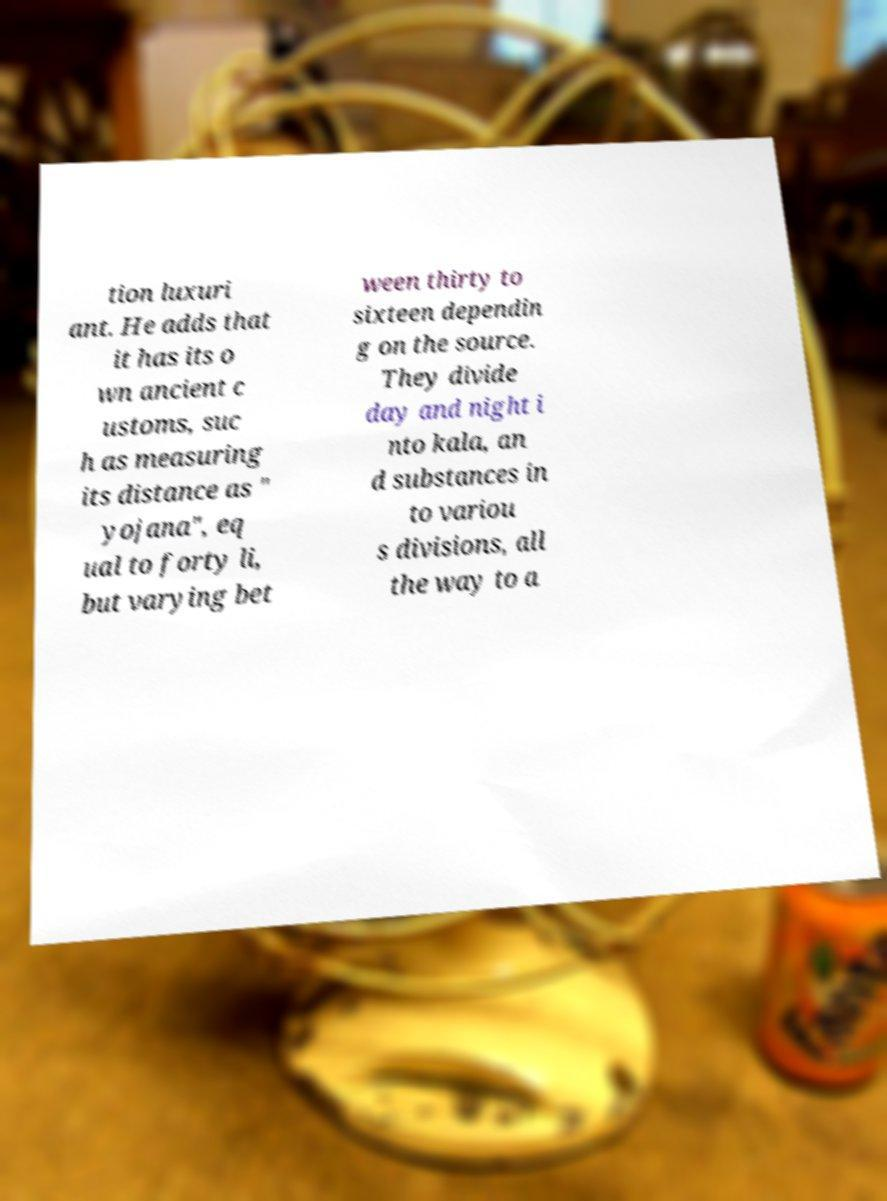Please identify and transcribe the text found in this image. tion luxuri ant. He adds that it has its o wn ancient c ustoms, suc h as measuring its distance as " yojana", eq ual to forty li, but varying bet ween thirty to sixteen dependin g on the source. They divide day and night i nto kala, an d substances in to variou s divisions, all the way to a 